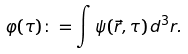<formula> <loc_0><loc_0><loc_500><loc_500>\varphi ( \tau ) \colon = \int \psi ( \vec { r } , \tau ) \, d ^ { 3 } r .</formula> 